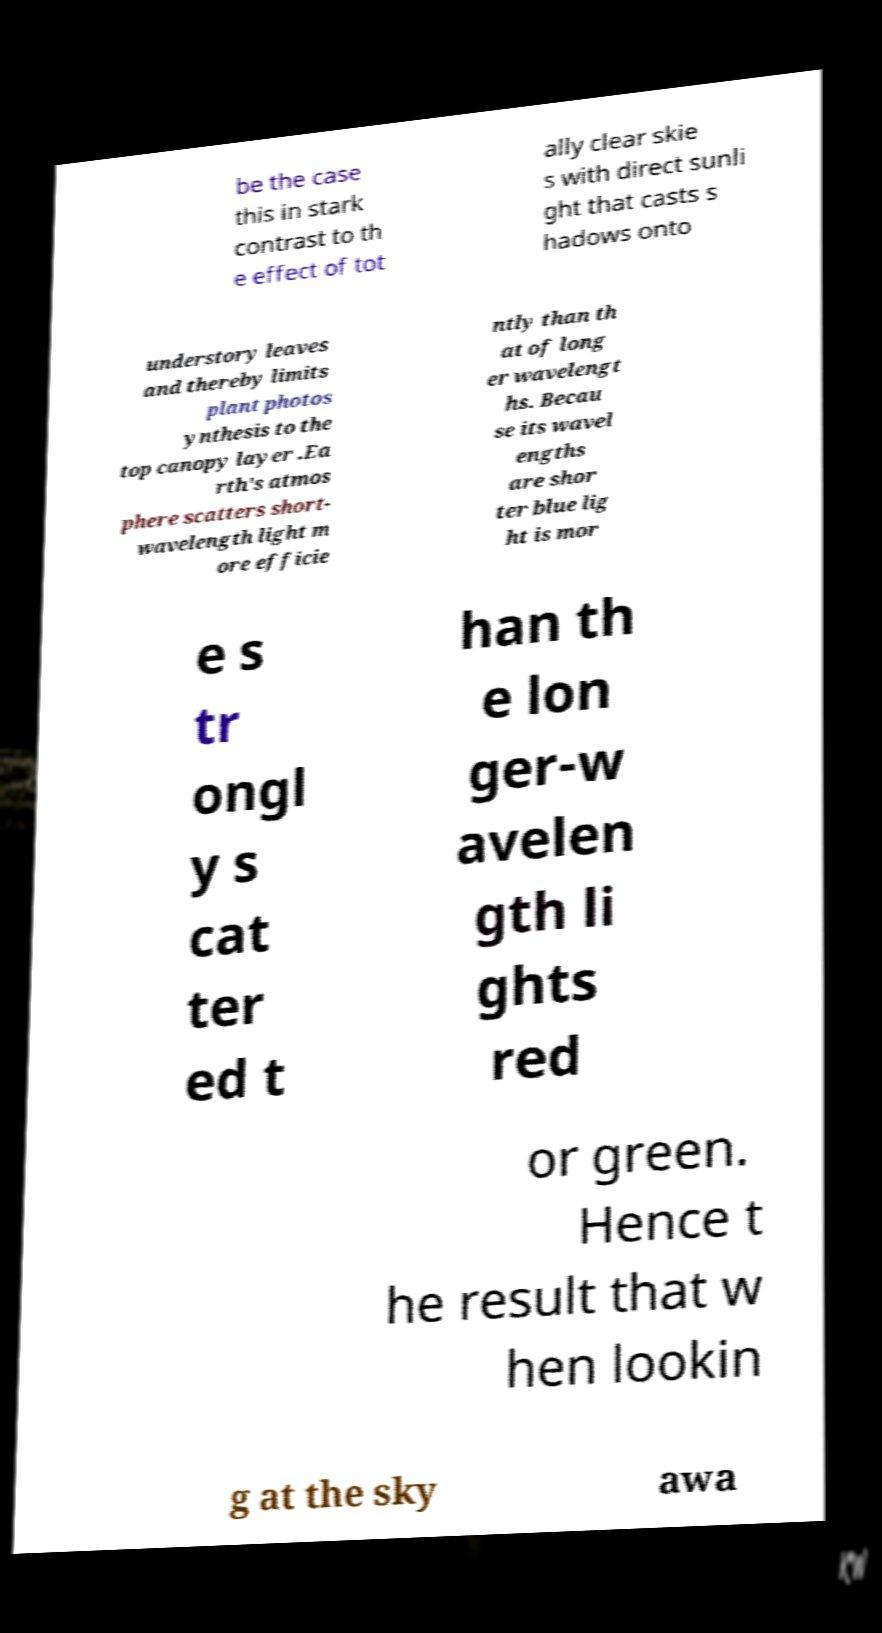There's text embedded in this image that I need extracted. Can you transcribe it verbatim? be the case this in stark contrast to th e effect of tot ally clear skie s with direct sunli ght that casts s hadows onto understory leaves and thereby limits plant photos ynthesis to the top canopy layer .Ea rth's atmos phere scatters short- wavelength light m ore efficie ntly than th at of long er wavelengt hs. Becau se its wavel engths are shor ter blue lig ht is mor e s tr ongl y s cat ter ed t han th e lon ger-w avelen gth li ghts red or green. Hence t he result that w hen lookin g at the sky awa 